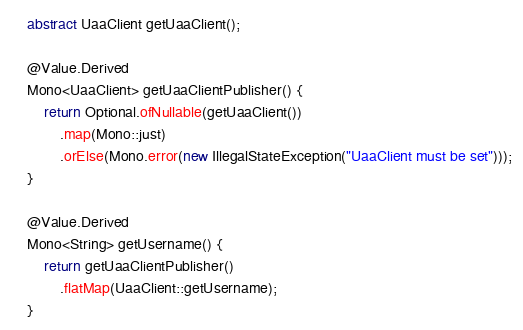Convert code to text. <code><loc_0><loc_0><loc_500><loc_500><_Java_>    abstract UaaClient getUaaClient();

    @Value.Derived
    Mono<UaaClient> getUaaClientPublisher() {
        return Optional.ofNullable(getUaaClient())
            .map(Mono::just)
            .orElse(Mono.error(new IllegalStateException("UaaClient must be set")));
    }

    @Value.Derived
    Mono<String> getUsername() {
        return getUaaClientPublisher()
            .flatMap(UaaClient::getUsername);
    }
</code> 